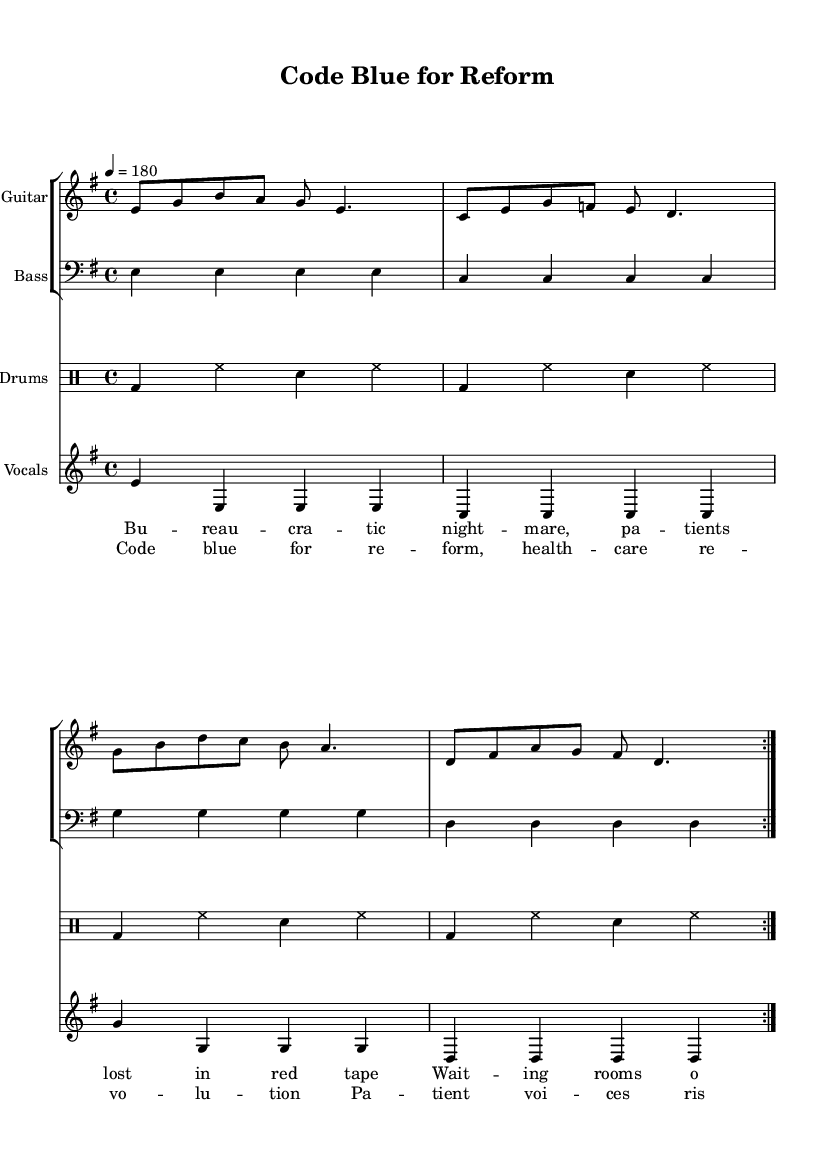What is the key signature of this music? The key signature is E minor, indicated by the presence of one sharp (F#) in the key signature section.
Answer: E minor What is the time signature of the piece? The time signature is 4/4, shown in the beginning of the score, indicating four beats per measure.
Answer: 4/4 What is the tempo marking for this piece? The tempo marking is indicated as "4 = 180," which specifies that there are 180 beats per minute.
Answer: 180 How many times is the verse repeated? The verse section marked in the lyrics is repeated twice as indicated by the repeat volta (the markings that show repeating sections).
Answer: 2 What instruments are included in the score? The score includes electric guitar, bass guitar, and drums as indicated by the staff names at the beginning of each staff.
Answer: Electric guitar, bass, drums What genre of music does this sheet represent? The sheet music represents punk rock, characterized by its fast pace, aggressive style, and themes of reform and rights.
Answer: Punk rock What themes are reflected in the lyrics of the song? The lyrics discuss healthcare reform and patient rights, mentioning red tape, waiting rooms, and the call for a healthcare revolution.
Answer: Healthcare reform, patient rights 